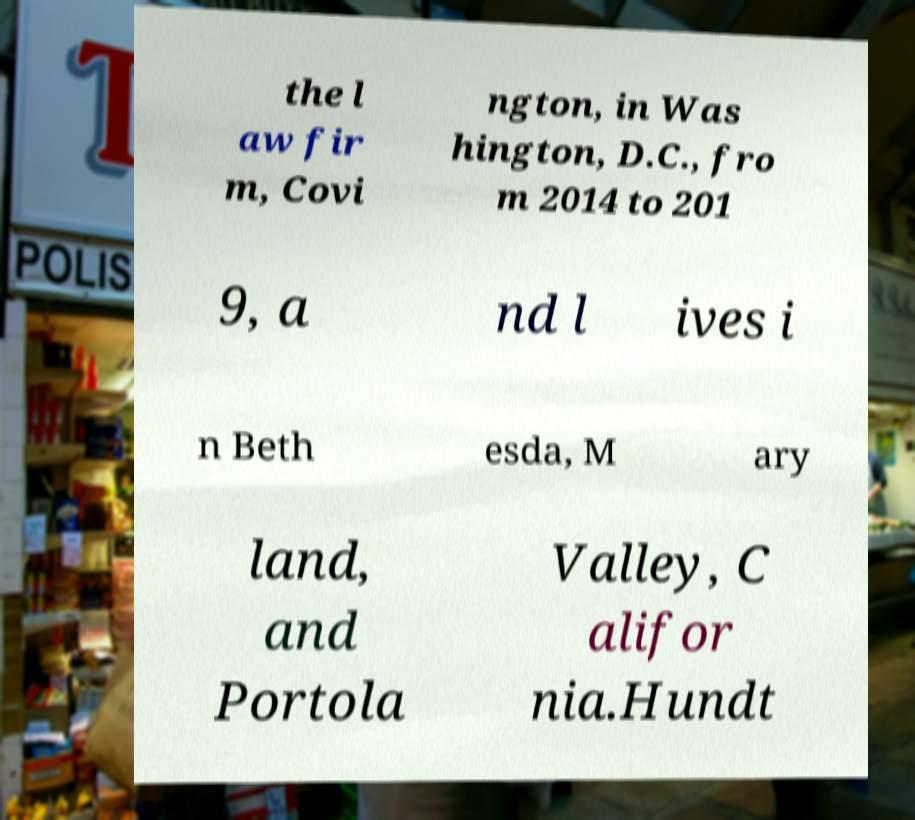There's text embedded in this image that I need extracted. Can you transcribe it verbatim? the l aw fir m, Covi ngton, in Was hington, D.C., fro m 2014 to 201 9, a nd l ives i n Beth esda, M ary land, and Portola Valley, C alifor nia.Hundt 